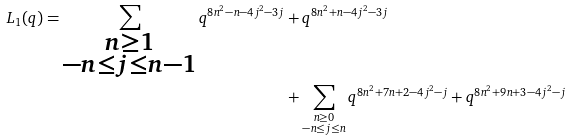Convert formula to latex. <formula><loc_0><loc_0><loc_500><loc_500>L _ { 1 } ( q ) = \sum _ { \substack { n \geq 1 \\ - n \leq j \leq n - 1 } } q ^ { 8 n ^ { 2 } - n - 4 j ^ { 2 } - 3 j } & + q ^ { 8 n ^ { 2 } + n - 4 j ^ { 2 } - 3 j } \\ & + \sum _ { \substack { n \geq 0 \\ - n \leq j \leq n } } q ^ { 8 n ^ { 2 } + 7 n + 2 - 4 j ^ { 2 } - j } + q ^ { 8 n ^ { 2 } + 9 n + 3 - 4 j ^ { 2 } - j }</formula> 